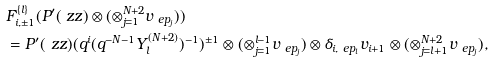<formula> <loc_0><loc_0><loc_500><loc_500>& F _ { i , \pm 1 } ^ { \{ l \} } ( P ^ { \prime } ( \ z z ) \otimes ( \otimes _ { j = 1 } ^ { N + 2 } v _ { \ e p _ { j } } ) ) \\ & = P ^ { \prime } ( \ z z ) ( q ^ { i } ( q ^ { - N - 1 } Y _ { l } ^ { ( N + 2 ) } ) ^ { - 1 } ) ^ { \pm 1 } \otimes ( \otimes _ { j = 1 } ^ { l - 1 } v _ { \ e p _ { j } } ) \otimes \delta _ { i , \ e p _ { l } } v _ { i + 1 } \otimes ( \otimes _ { j = l + 1 } ^ { N + 2 } v _ { \ e p _ { j } } ) ,</formula> 